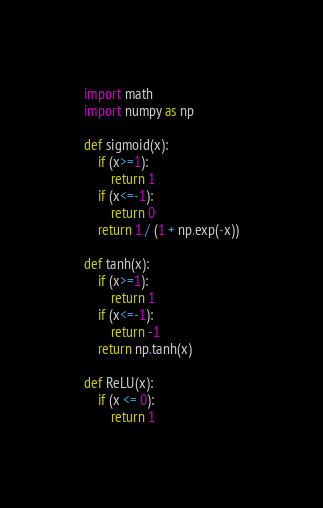<code> <loc_0><loc_0><loc_500><loc_500><_Python_>
import math
import numpy as np

def sigmoid(x):
    if (x>=1):
        return 1
    if (x<=-1):
        return 0
    return 1 / (1 + np.exp(-x))

def tanh(x):
    if (x>=1):
        return 1
    if (x<=-1):
        return -1
    return np.tanh(x)

def ReLU(x):
    if (x <= 0):
        return 1</code> 